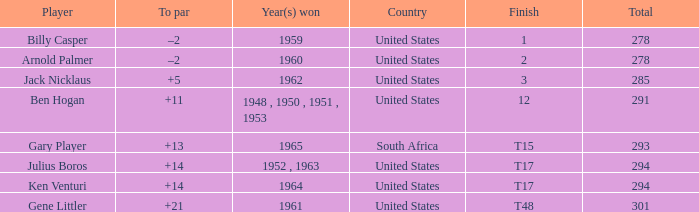What is Finish, when Country is "United States", and when To Par is "+21"? T48. 